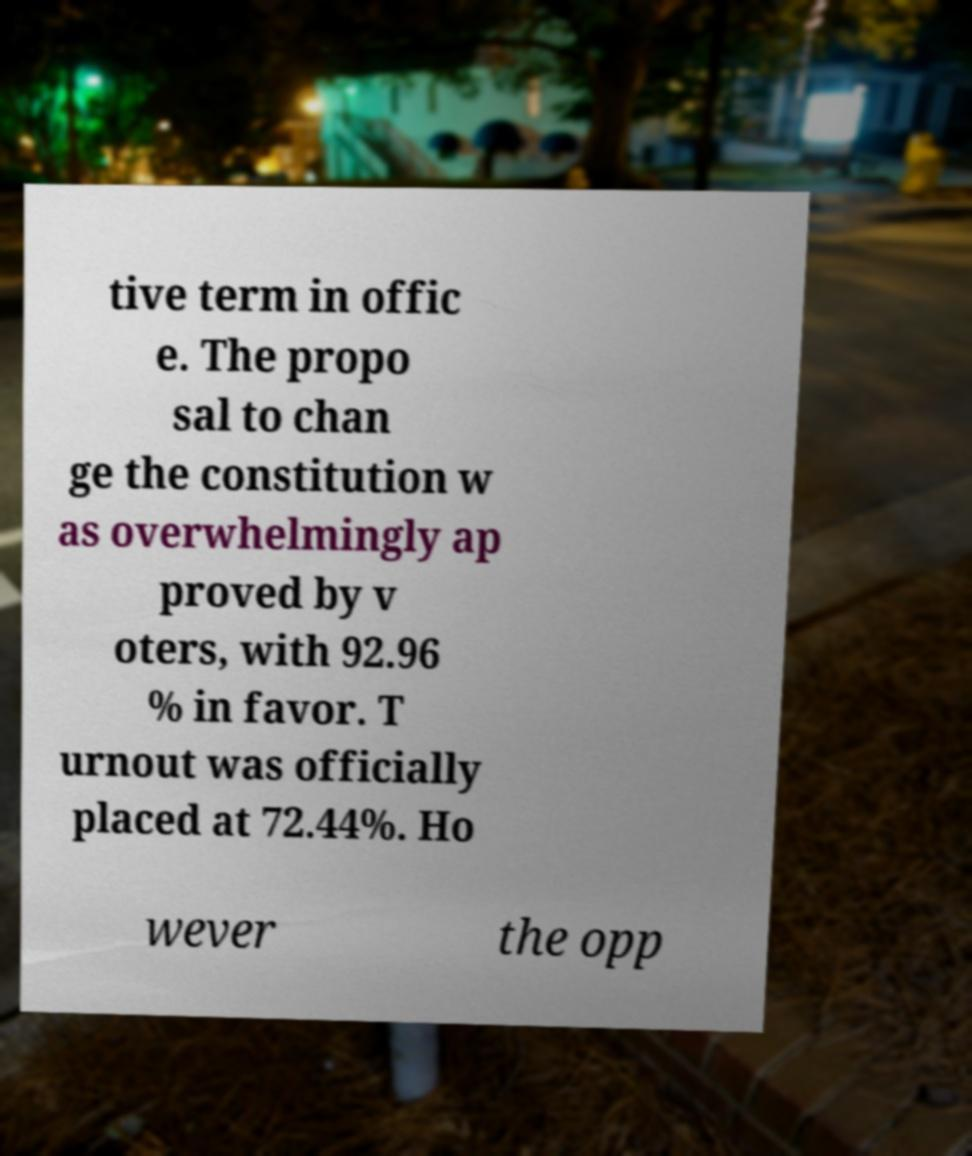What messages or text are displayed in this image? I need them in a readable, typed format. tive term in offic e. The propo sal to chan ge the constitution w as overwhelmingly ap proved by v oters, with 92.96 % in favor. T urnout was officially placed at 72.44%. Ho wever the opp 